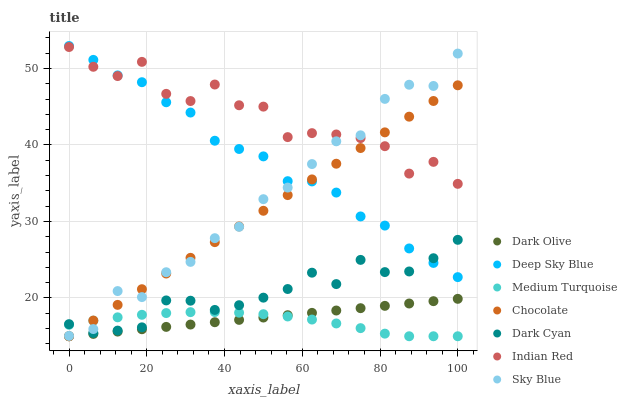Does Medium Turquoise have the minimum area under the curve?
Answer yes or no. Yes. Does Indian Red have the maximum area under the curve?
Answer yes or no. Yes. Does Dark Olive have the minimum area under the curve?
Answer yes or no. No. Does Dark Olive have the maximum area under the curve?
Answer yes or no. No. Is Dark Olive the smoothest?
Answer yes or no. Yes. Is Indian Red the roughest?
Answer yes or no. Yes. Is Chocolate the smoothest?
Answer yes or no. No. Is Chocolate the roughest?
Answer yes or no. No. Does Medium Turquoise have the lowest value?
Answer yes or no. Yes. Does Indian Red have the lowest value?
Answer yes or no. No. Does Deep Sky Blue have the highest value?
Answer yes or no. Yes. Does Dark Olive have the highest value?
Answer yes or no. No. Is Dark Olive less than Indian Red?
Answer yes or no. Yes. Is Deep Sky Blue greater than Medium Turquoise?
Answer yes or no. Yes. Does Deep Sky Blue intersect Dark Cyan?
Answer yes or no. Yes. Is Deep Sky Blue less than Dark Cyan?
Answer yes or no. No. Is Deep Sky Blue greater than Dark Cyan?
Answer yes or no. No. Does Dark Olive intersect Indian Red?
Answer yes or no. No. 